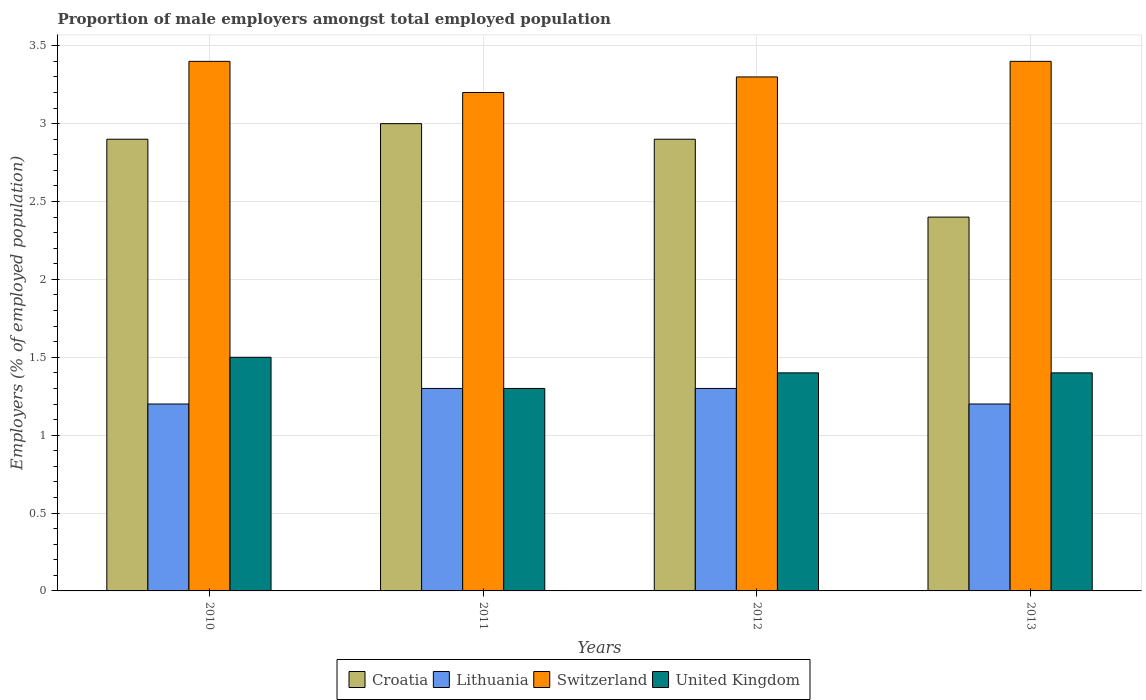How many groups of bars are there?
Provide a short and direct response. 4. Are the number of bars per tick equal to the number of legend labels?
Your answer should be very brief. Yes. Are the number of bars on each tick of the X-axis equal?
Make the answer very short. Yes. How many bars are there on the 4th tick from the left?
Keep it short and to the point. 4. How many bars are there on the 4th tick from the right?
Your answer should be very brief. 4. In how many cases, is the number of bars for a given year not equal to the number of legend labels?
Provide a succinct answer. 0. What is the proportion of male employers in Croatia in 2010?
Make the answer very short. 2.9. Across all years, what is the minimum proportion of male employers in Switzerland?
Offer a terse response. 3.2. What is the difference between the proportion of male employers in Switzerland in 2011 and that in 2013?
Ensure brevity in your answer.  -0.2. What is the difference between the proportion of male employers in Croatia in 2011 and the proportion of male employers in Switzerland in 2013?
Your answer should be compact. -0.4. What is the average proportion of male employers in Switzerland per year?
Make the answer very short. 3.33. In the year 2011, what is the difference between the proportion of male employers in Lithuania and proportion of male employers in United Kingdom?
Provide a short and direct response. 0. What is the ratio of the proportion of male employers in United Kingdom in 2011 to that in 2012?
Offer a very short reply. 0.93. Is the difference between the proportion of male employers in Lithuania in 2011 and 2013 greater than the difference between the proportion of male employers in United Kingdom in 2011 and 2013?
Offer a terse response. Yes. What is the difference between the highest and the second highest proportion of male employers in United Kingdom?
Keep it short and to the point. 0.1. What is the difference between the highest and the lowest proportion of male employers in United Kingdom?
Provide a short and direct response. 0.2. Is the sum of the proportion of male employers in Lithuania in 2010 and 2013 greater than the maximum proportion of male employers in United Kingdom across all years?
Your answer should be very brief. Yes. Is it the case that in every year, the sum of the proportion of male employers in Croatia and proportion of male employers in United Kingdom is greater than the sum of proportion of male employers in Lithuania and proportion of male employers in Switzerland?
Your answer should be very brief. Yes. What does the 1st bar from the left in 2011 represents?
Offer a very short reply. Croatia. How many bars are there?
Offer a very short reply. 16. How many years are there in the graph?
Make the answer very short. 4. What is the difference between two consecutive major ticks on the Y-axis?
Your answer should be compact. 0.5. How are the legend labels stacked?
Offer a very short reply. Horizontal. What is the title of the graph?
Provide a short and direct response. Proportion of male employers amongst total employed population. What is the label or title of the X-axis?
Provide a short and direct response. Years. What is the label or title of the Y-axis?
Your answer should be compact. Employers (% of employed population). What is the Employers (% of employed population) in Croatia in 2010?
Your answer should be compact. 2.9. What is the Employers (% of employed population) of Lithuania in 2010?
Offer a very short reply. 1.2. What is the Employers (% of employed population) in Switzerland in 2010?
Offer a very short reply. 3.4. What is the Employers (% of employed population) in United Kingdom in 2010?
Keep it short and to the point. 1.5. What is the Employers (% of employed population) of Lithuania in 2011?
Give a very brief answer. 1.3. What is the Employers (% of employed population) of Switzerland in 2011?
Your answer should be very brief. 3.2. What is the Employers (% of employed population) in United Kingdom in 2011?
Give a very brief answer. 1.3. What is the Employers (% of employed population) in Croatia in 2012?
Your answer should be very brief. 2.9. What is the Employers (% of employed population) of Lithuania in 2012?
Your response must be concise. 1.3. What is the Employers (% of employed population) of Switzerland in 2012?
Provide a short and direct response. 3.3. What is the Employers (% of employed population) in United Kingdom in 2012?
Your answer should be compact. 1.4. What is the Employers (% of employed population) of Croatia in 2013?
Ensure brevity in your answer.  2.4. What is the Employers (% of employed population) of Lithuania in 2013?
Provide a succinct answer. 1.2. What is the Employers (% of employed population) of Switzerland in 2013?
Provide a short and direct response. 3.4. What is the Employers (% of employed population) of United Kingdom in 2013?
Offer a terse response. 1.4. Across all years, what is the maximum Employers (% of employed population) in Croatia?
Give a very brief answer. 3. Across all years, what is the maximum Employers (% of employed population) in Lithuania?
Make the answer very short. 1.3. Across all years, what is the maximum Employers (% of employed population) in Switzerland?
Offer a terse response. 3.4. Across all years, what is the maximum Employers (% of employed population) in United Kingdom?
Offer a very short reply. 1.5. Across all years, what is the minimum Employers (% of employed population) of Croatia?
Provide a succinct answer. 2.4. Across all years, what is the minimum Employers (% of employed population) in Lithuania?
Your answer should be very brief. 1.2. Across all years, what is the minimum Employers (% of employed population) in Switzerland?
Your response must be concise. 3.2. Across all years, what is the minimum Employers (% of employed population) in United Kingdom?
Offer a terse response. 1.3. What is the total Employers (% of employed population) of Croatia in the graph?
Ensure brevity in your answer.  11.2. What is the total Employers (% of employed population) of Lithuania in the graph?
Provide a succinct answer. 5. What is the total Employers (% of employed population) in United Kingdom in the graph?
Keep it short and to the point. 5.6. What is the difference between the Employers (% of employed population) of Croatia in 2010 and that in 2011?
Keep it short and to the point. -0.1. What is the difference between the Employers (% of employed population) of Lithuania in 2010 and that in 2011?
Provide a short and direct response. -0.1. What is the difference between the Employers (% of employed population) of Switzerland in 2010 and that in 2011?
Offer a very short reply. 0.2. What is the difference between the Employers (% of employed population) in Croatia in 2010 and that in 2012?
Provide a succinct answer. 0. What is the difference between the Employers (% of employed population) in Lithuania in 2010 and that in 2012?
Your answer should be very brief. -0.1. What is the difference between the Employers (% of employed population) in Croatia in 2010 and that in 2013?
Provide a short and direct response. 0.5. What is the difference between the Employers (% of employed population) in Lithuania in 2010 and that in 2013?
Ensure brevity in your answer.  0. What is the difference between the Employers (% of employed population) in Switzerland in 2010 and that in 2013?
Offer a very short reply. 0. What is the difference between the Employers (% of employed population) in Switzerland in 2011 and that in 2012?
Make the answer very short. -0.1. What is the difference between the Employers (% of employed population) in United Kingdom in 2011 and that in 2012?
Provide a short and direct response. -0.1. What is the difference between the Employers (% of employed population) of Croatia in 2011 and that in 2013?
Your answer should be very brief. 0.6. What is the difference between the Employers (% of employed population) in United Kingdom in 2011 and that in 2013?
Provide a succinct answer. -0.1. What is the difference between the Employers (% of employed population) of Croatia in 2012 and that in 2013?
Your answer should be compact. 0.5. What is the difference between the Employers (% of employed population) of Switzerland in 2012 and that in 2013?
Ensure brevity in your answer.  -0.1. What is the difference between the Employers (% of employed population) in Lithuania in 2010 and the Employers (% of employed population) in Switzerland in 2011?
Your answer should be compact. -2. What is the difference between the Employers (% of employed population) in Lithuania in 2010 and the Employers (% of employed population) in United Kingdom in 2011?
Keep it short and to the point. -0.1. What is the difference between the Employers (% of employed population) of Switzerland in 2010 and the Employers (% of employed population) of United Kingdom in 2011?
Offer a very short reply. 2.1. What is the difference between the Employers (% of employed population) of Croatia in 2010 and the Employers (% of employed population) of United Kingdom in 2012?
Make the answer very short. 1.5. What is the difference between the Employers (% of employed population) of Lithuania in 2010 and the Employers (% of employed population) of Switzerland in 2012?
Your response must be concise. -2.1. What is the difference between the Employers (% of employed population) in Lithuania in 2010 and the Employers (% of employed population) in United Kingdom in 2012?
Offer a terse response. -0.2. What is the difference between the Employers (% of employed population) of Croatia in 2010 and the Employers (% of employed population) of Switzerland in 2013?
Your answer should be compact. -0.5. What is the difference between the Employers (% of employed population) of Lithuania in 2010 and the Employers (% of employed population) of Switzerland in 2013?
Your answer should be compact. -2.2. What is the difference between the Employers (% of employed population) in Croatia in 2011 and the Employers (% of employed population) in United Kingdom in 2012?
Offer a very short reply. 1.6. What is the difference between the Employers (% of employed population) in Lithuania in 2011 and the Employers (% of employed population) in Switzerland in 2012?
Provide a short and direct response. -2. What is the difference between the Employers (% of employed population) of Lithuania in 2011 and the Employers (% of employed population) of United Kingdom in 2012?
Your response must be concise. -0.1. What is the difference between the Employers (% of employed population) of Croatia in 2011 and the Employers (% of employed population) of United Kingdom in 2013?
Ensure brevity in your answer.  1.6. What is the difference between the Employers (% of employed population) in Lithuania in 2011 and the Employers (% of employed population) in United Kingdom in 2013?
Your response must be concise. -0.1. What is the difference between the Employers (% of employed population) of Croatia in 2012 and the Employers (% of employed population) of United Kingdom in 2013?
Give a very brief answer. 1.5. What is the difference between the Employers (% of employed population) in Switzerland in 2012 and the Employers (% of employed population) in United Kingdom in 2013?
Offer a very short reply. 1.9. What is the average Employers (% of employed population) of Croatia per year?
Ensure brevity in your answer.  2.8. What is the average Employers (% of employed population) in Lithuania per year?
Your response must be concise. 1.25. What is the average Employers (% of employed population) of Switzerland per year?
Provide a short and direct response. 3.33. In the year 2010, what is the difference between the Employers (% of employed population) of Croatia and Employers (% of employed population) of Lithuania?
Make the answer very short. 1.7. In the year 2010, what is the difference between the Employers (% of employed population) of Croatia and Employers (% of employed population) of United Kingdom?
Your answer should be compact. 1.4. In the year 2010, what is the difference between the Employers (% of employed population) in Lithuania and Employers (% of employed population) in Switzerland?
Make the answer very short. -2.2. In the year 2010, what is the difference between the Employers (% of employed population) in Lithuania and Employers (% of employed population) in United Kingdom?
Your response must be concise. -0.3. In the year 2010, what is the difference between the Employers (% of employed population) of Switzerland and Employers (% of employed population) of United Kingdom?
Offer a very short reply. 1.9. In the year 2011, what is the difference between the Employers (% of employed population) in Croatia and Employers (% of employed population) in Lithuania?
Ensure brevity in your answer.  1.7. In the year 2011, what is the difference between the Employers (% of employed population) of Croatia and Employers (% of employed population) of Switzerland?
Offer a terse response. -0.2. In the year 2011, what is the difference between the Employers (% of employed population) in Switzerland and Employers (% of employed population) in United Kingdom?
Ensure brevity in your answer.  1.9. In the year 2012, what is the difference between the Employers (% of employed population) of Croatia and Employers (% of employed population) of Lithuania?
Offer a very short reply. 1.6. In the year 2012, what is the difference between the Employers (% of employed population) in Croatia and Employers (% of employed population) in Switzerland?
Provide a short and direct response. -0.4. In the year 2012, what is the difference between the Employers (% of employed population) of Croatia and Employers (% of employed population) of United Kingdom?
Your answer should be very brief. 1.5. In the year 2012, what is the difference between the Employers (% of employed population) of Lithuania and Employers (% of employed population) of United Kingdom?
Keep it short and to the point. -0.1. In the year 2013, what is the difference between the Employers (% of employed population) in Croatia and Employers (% of employed population) in Lithuania?
Make the answer very short. 1.2. In the year 2013, what is the difference between the Employers (% of employed population) of Switzerland and Employers (% of employed population) of United Kingdom?
Provide a succinct answer. 2. What is the ratio of the Employers (% of employed population) of Croatia in 2010 to that in 2011?
Provide a short and direct response. 0.97. What is the ratio of the Employers (% of employed population) of Lithuania in 2010 to that in 2011?
Your answer should be compact. 0.92. What is the ratio of the Employers (% of employed population) of Switzerland in 2010 to that in 2011?
Offer a terse response. 1.06. What is the ratio of the Employers (% of employed population) of United Kingdom in 2010 to that in 2011?
Keep it short and to the point. 1.15. What is the ratio of the Employers (% of employed population) in Croatia in 2010 to that in 2012?
Your answer should be compact. 1. What is the ratio of the Employers (% of employed population) in Switzerland in 2010 to that in 2012?
Offer a very short reply. 1.03. What is the ratio of the Employers (% of employed population) in United Kingdom in 2010 to that in 2012?
Provide a short and direct response. 1.07. What is the ratio of the Employers (% of employed population) in Croatia in 2010 to that in 2013?
Your answer should be very brief. 1.21. What is the ratio of the Employers (% of employed population) in Lithuania in 2010 to that in 2013?
Your answer should be compact. 1. What is the ratio of the Employers (% of employed population) in United Kingdom in 2010 to that in 2013?
Your response must be concise. 1.07. What is the ratio of the Employers (% of employed population) of Croatia in 2011 to that in 2012?
Offer a terse response. 1.03. What is the ratio of the Employers (% of employed population) in Lithuania in 2011 to that in 2012?
Your response must be concise. 1. What is the ratio of the Employers (% of employed population) of Switzerland in 2011 to that in 2012?
Your answer should be compact. 0.97. What is the ratio of the Employers (% of employed population) of Croatia in 2012 to that in 2013?
Give a very brief answer. 1.21. What is the ratio of the Employers (% of employed population) of Switzerland in 2012 to that in 2013?
Offer a very short reply. 0.97. What is the difference between the highest and the second highest Employers (% of employed population) of Croatia?
Ensure brevity in your answer.  0.1. What is the difference between the highest and the lowest Employers (% of employed population) in Croatia?
Provide a succinct answer. 0.6. What is the difference between the highest and the lowest Employers (% of employed population) in United Kingdom?
Make the answer very short. 0.2. 